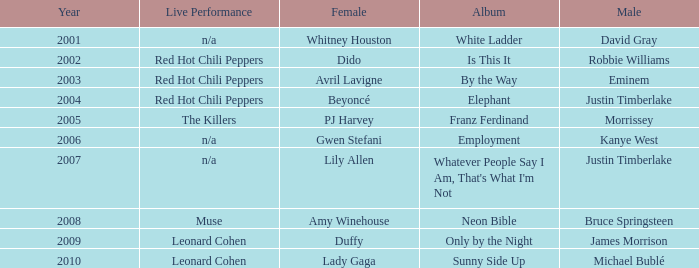Who is the male partner for amy winehouse? Bruce Springsteen. 